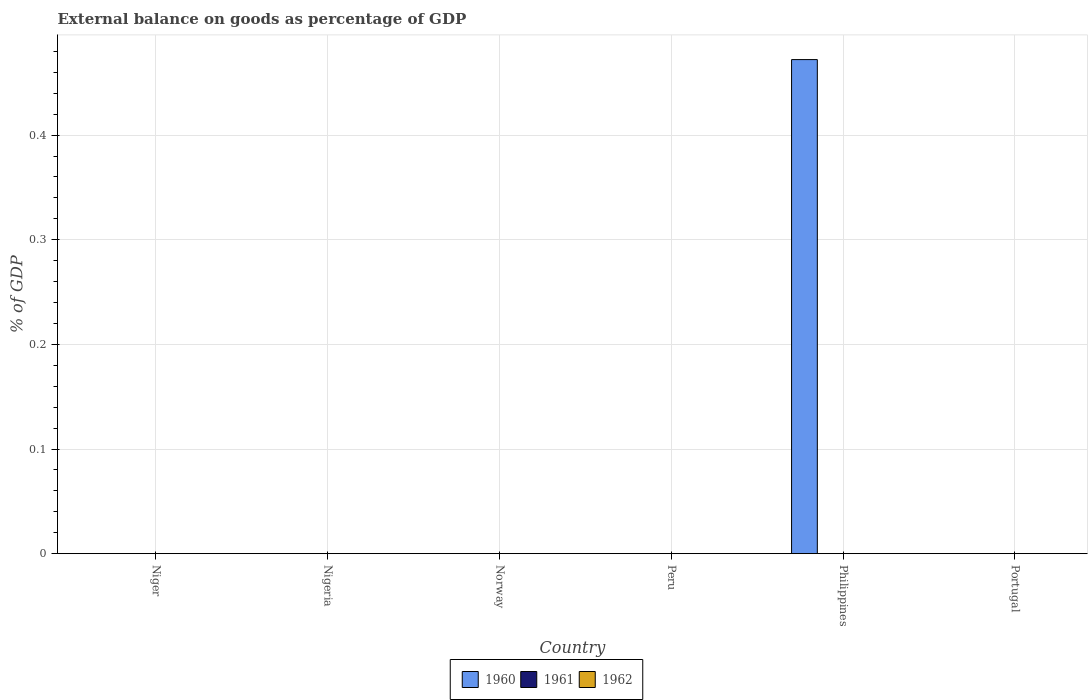Are the number of bars on each tick of the X-axis equal?
Offer a very short reply. No. How many bars are there on the 3rd tick from the right?
Give a very brief answer. 0. In how many cases, is the number of bars for a given country not equal to the number of legend labels?
Your answer should be very brief. 6. Across all countries, what is the maximum external balance on goods as percentage of GDP in 1960?
Keep it short and to the point. 0.47. Across all countries, what is the minimum external balance on goods as percentage of GDP in 1960?
Give a very brief answer. 0. What is the total external balance on goods as percentage of GDP in 1961 in the graph?
Your answer should be compact. 0. What is the difference between the highest and the lowest external balance on goods as percentage of GDP in 1960?
Your answer should be very brief. 0.47. In how many countries, is the external balance on goods as percentage of GDP in 1960 greater than the average external balance on goods as percentage of GDP in 1960 taken over all countries?
Offer a very short reply. 1. Are all the bars in the graph horizontal?
Your answer should be compact. No. How many countries are there in the graph?
Give a very brief answer. 6. What is the difference between two consecutive major ticks on the Y-axis?
Your response must be concise. 0.1. What is the title of the graph?
Ensure brevity in your answer.  External balance on goods as percentage of GDP. Does "1969" appear as one of the legend labels in the graph?
Give a very brief answer. No. What is the label or title of the X-axis?
Offer a very short reply. Country. What is the label or title of the Y-axis?
Ensure brevity in your answer.  % of GDP. What is the % of GDP of 1960 in Niger?
Offer a very short reply. 0. What is the % of GDP in 1961 in Niger?
Ensure brevity in your answer.  0. What is the % of GDP in 1962 in Niger?
Make the answer very short. 0. What is the % of GDP of 1960 in Nigeria?
Keep it short and to the point. 0. What is the % of GDP in 1961 in Nigeria?
Give a very brief answer. 0. What is the % of GDP in 1962 in Norway?
Your answer should be very brief. 0. What is the % of GDP in 1961 in Peru?
Make the answer very short. 0. What is the % of GDP of 1960 in Philippines?
Offer a very short reply. 0.47. What is the % of GDP of 1961 in Philippines?
Offer a terse response. 0. What is the % of GDP of 1961 in Portugal?
Provide a short and direct response. 0. Across all countries, what is the maximum % of GDP of 1960?
Your response must be concise. 0.47. Across all countries, what is the minimum % of GDP of 1960?
Your answer should be compact. 0. What is the total % of GDP in 1960 in the graph?
Your response must be concise. 0.47. What is the total % of GDP in 1961 in the graph?
Offer a very short reply. 0. What is the total % of GDP of 1962 in the graph?
Make the answer very short. 0. What is the average % of GDP of 1960 per country?
Offer a very short reply. 0.08. What is the difference between the highest and the lowest % of GDP in 1960?
Make the answer very short. 0.47. 